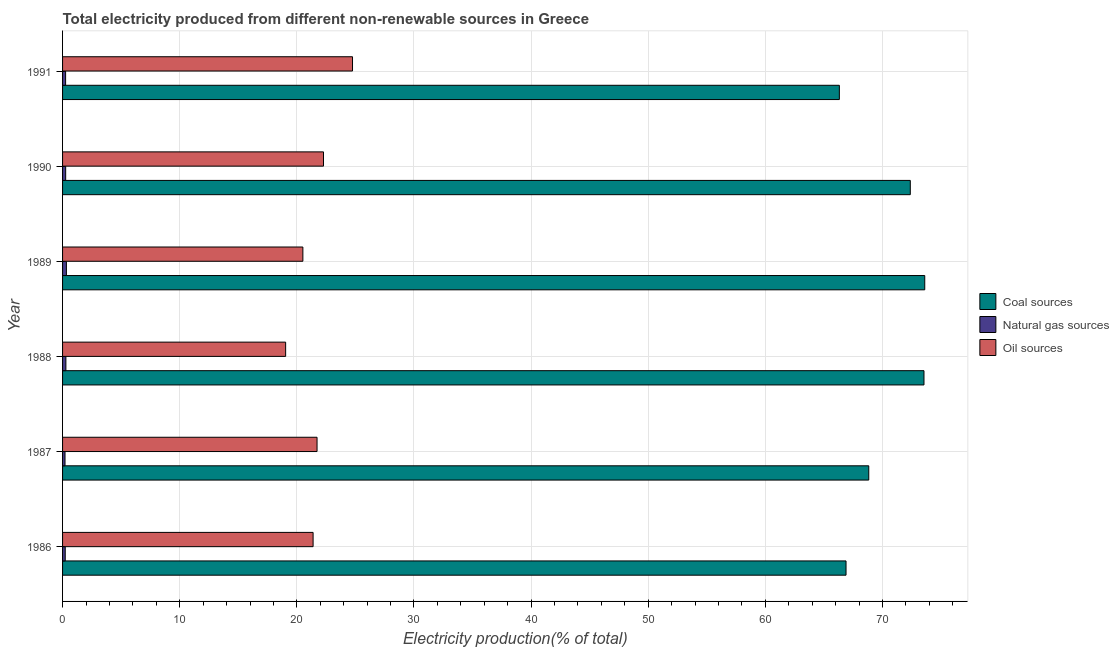How many groups of bars are there?
Your answer should be very brief. 6. Are the number of bars per tick equal to the number of legend labels?
Ensure brevity in your answer.  Yes. Are the number of bars on each tick of the Y-axis equal?
Your answer should be compact. Yes. How many bars are there on the 2nd tick from the bottom?
Offer a terse response. 3. In how many cases, is the number of bars for a given year not equal to the number of legend labels?
Provide a short and direct response. 0. What is the percentage of electricity produced by oil sources in 1991?
Offer a very short reply. 24.75. Across all years, what is the maximum percentage of electricity produced by natural gas?
Provide a short and direct response. 0.33. Across all years, what is the minimum percentage of electricity produced by coal?
Make the answer very short. 66.31. In which year was the percentage of electricity produced by coal maximum?
Your answer should be compact. 1989. What is the total percentage of electricity produced by coal in the graph?
Your response must be concise. 421.52. What is the difference between the percentage of electricity produced by oil sources in 1989 and that in 1990?
Make the answer very short. -1.76. What is the difference between the percentage of electricity produced by oil sources in 1988 and the percentage of electricity produced by natural gas in 1989?
Provide a succinct answer. 18.72. What is the average percentage of electricity produced by natural gas per year?
Give a very brief answer. 0.26. In the year 1989, what is the difference between the percentage of electricity produced by oil sources and percentage of electricity produced by natural gas?
Offer a terse response. 20.19. What is the ratio of the percentage of electricity produced by coal in 1989 to that in 1991?
Offer a very short reply. 1.11. What is the difference between the highest and the second highest percentage of electricity produced by natural gas?
Ensure brevity in your answer.  0.04. What is the difference between the highest and the lowest percentage of electricity produced by natural gas?
Keep it short and to the point. 0.12. What does the 3rd bar from the top in 1987 represents?
Offer a terse response. Coal sources. What does the 2nd bar from the bottom in 1986 represents?
Your response must be concise. Natural gas sources. Is it the case that in every year, the sum of the percentage of electricity produced by coal and percentage of electricity produced by natural gas is greater than the percentage of electricity produced by oil sources?
Offer a very short reply. Yes. How many bars are there?
Keep it short and to the point. 18. Are all the bars in the graph horizontal?
Provide a succinct answer. Yes. How many years are there in the graph?
Provide a short and direct response. 6. What is the difference between two consecutive major ticks on the X-axis?
Ensure brevity in your answer.  10. Are the values on the major ticks of X-axis written in scientific E-notation?
Keep it short and to the point. No. Does the graph contain any zero values?
Provide a succinct answer. No. Does the graph contain grids?
Offer a terse response. Yes. Where does the legend appear in the graph?
Keep it short and to the point. Center right. How many legend labels are there?
Keep it short and to the point. 3. What is the title of the graph?
Your answer should be compact. Total electricity produced from different non-renewable sources in Greece. Does "Social Insurance" appear as one of the legend labels in the graph?
Provide a succinct answer. No. What is the label or title of the Y-axis?
Make the answer very short. Year. What is the Electricity production(% of total) in Coal sources in 1986?
Ensure brevity in your answer.  66.88. What is the Electricity production(% of total) of Natural gas sources in 1986?
Give a very brief answer. 0.23. What is the Electricity production(% of total) of Oil sources in 1986?
Your answer should be compact. 21.39. What is the Electricity production(% of total) of Coal sources in 1987?
Your response must be concise. 68.82. What is the Electricity production(% of total) of Natural gas sources in 1987?
Ensure brevity in your answer.  0.21. What is the Electricity production(% of total) of Oil sources in 1987?
Your response must be concise. 21.72. What is the Electricity production(% of total) in Coal sources in 1988?
Offer a terse response. 73.54. What is the Electricity production(% of total) in Natural gas sources in 1988?
Your response must be concise. 0.28. What is the Electricity production(% of total) of Oil sources in 1988?
Provide a succinct answer. 19.04. What is the Electricity production(% of total) in Coal sources in 1989?
Provide a short and direct response. 73.6. What is the Electricity production(% of total) of Natural gas sources in 1989?
Offer a terse response. 0.33. What is the Electricity production(% of total) of Oil sources in 1989?
Keep it short and to the point. 20.51. What is the Electricity production(% of total) of Coal sources in 1990?
Make the answer very short. 72.37. What is the Electricity production(% of total) in Natural gas sources in 1990?
Provide a succinct answer. 0.26. What is the Electricity production(% of total) of Oil sources in 1990?
Offer a very short reply. 22.27. What is the Electricity production(% of total) in Coal sources in 1991?
Ensure brevity in your answer.  66.31. What is the Electricity production(% of total) of Natural gas sources in 1991?
Provide a succinct answer. 0.26. What is the Electricity production(% of total) of Oil sources in 1991?
Offer a very short reply. 24.75. Across all years, what is the maximum Electricity production(% of total) of Coal sources?
Your response must be concise. 73.6. Across all years, what is the maximum Electricity production(% of total) in Natural gas sources?
Your answer should be very brief. 0.33. Across all years, what is the maximum Electricity production(% of total) of Oil sources?
Ensure brevity in your answer.  24.75. Across all years, what is the minimum Electricity production(% of total) in Coal sources?
Your answer should be very brief. 66.31. Across all years, what is the minimum Electricity production(% of total) in Natural gas sources?
Your response must be concise. 0.21. Across all years, what is the minimum Electricity production(% of total) in Oil sources?
Ensure brevity in your answer.  19.04. What is the total Electricity production(% of total) of Coal sources in the graph?
Ensure brevity in your answer.  421.52. What is the total Electricity production(% of total) in Natural gas sources in the graph?
Ensure brevity in your answer.  1.57. What is the total Electricity production(% of total) in Oil sources in the graph?
Make the answer very short. 129.7. What is the difference between the Electricity production(% of total) in Coal sources in 1986 and that in 1987?
Your response must be concise. -1.94. What is the difference between the Electricity production(% of total) of Natural gas sources in 1986 and that in 1987?
Make the answer very short. 0.02. What is the difference between the Electricity production(% of total) in Oil sources in 1986 and that in 1987?
Your response must be concise. -0.34. What is the difference between the Electricity production(% of total) in Coal sources in 1986 and that in 1988?
Keep it short and to the point. -6.65. What is the difference between the Electricity production(% of total) in Natural gas sources in 1986 and that in 1988?
Ensure brevity in your answer.  -0.06. What is the difference between the Electricity production(% of total) in Oil sources in 1986 and that in 1988?
Give a very brief answer. 2.34. What is the difference between the Electricity production(% of total) of Coal sources in 1986 and that in 1989?
Make the answer very short. -6.72. What is the difference between the Electricity production(% of total) of Natural gas sources in 1986 and that in 1989?
Your answer should be compact. -0.1. What is the difference between the Electricity production(% of total) of Oil sources in 1986 and that in 1989?
Provide a short and direct response. 0.87. What is the difference between the Electricity production(% of total) in Coal sources in 1986 and that in 1990?
Ensure brevity in your answer.  -5.49. What is the difference between the Electricity production(% of total) of Natural gas sources in 1986 and that in 1990?
Your answer should be very brief. -0.04. What is the difference between the Electricity production(% of total) in Oil sources in 1986 and that in 1990?
Make the answer very short. -0.89. What is the difference between the Electricity production(% of total) in Coal sources in 1986 and that in 1991?
Offer a very short reply. 0.57. What is the difference between the Electricity production(% of total) in Natural gas sources in 1986 and that in 1991?
Offer a very short reply. -0.03. What is the difference between the Electricity production(% of total) in Oil sources in 1986 and that in 1991?
Your response must be concise. -3.36. What is the difference between the Electricity production(% of total) in Coal sources in 1987 and that in 1988?
Your response must be concise. -4.71. What is the difference between the Electricity production(% of total) in Natural gas sources in 1987 and that in 1988?
Your answer should be compact. -0.07. What is the difference between the Electricity production(% of total) of Oil sources in 1987 and that in 1988?
Your response must be concise. 2.68. What is the difference between the Electricity production(% of total) of Coal sources in 1987 and that in 1989?
Keep it short and to the point. -4.78. What is the difference between the Electricity production(% of total) in Natural gas sources in 1987 and that in 1989?
Make the answer very short. -0.12. What is the difference between the Electricity production(% of total) of Oil sources in 1987 and that in 1989?
Offer a very short reply. 1.21. What is the difference between the Electricity production(% of total) of Coal sources in 1987 and that in 1990?
Offer a terse response. -3.55. What is the difference between the Electricity production(% of total) of Natural gas sources in 1987 and that in 1990?
Your response must be concise. -0.06. What is the difference between the Electricity production(% of total) in Oil sources in 1987 and that in 1990?
Provide a succinct answer. -0.55. What is the difference between the Electricity production(% of total) in Coal sources in 1987 and that in 1991?
Your response must be concise. 2.51. What is the difference between the Electricity production(% of total) of Natural gas sources in 1987 and that in 1991?
Your response must be concise. -0.05. What is the difference between the Electricity production(% of total) in Oil sources in 1987 and that in 1991?
Your answer should be compact. -3.03. What is the difference between the Electricity production(% of total) of Coal sources in 1988 and that in 1989?
Provide a short and direct response. -0.07. What is the difference between the Electricity production(% of total) of Natural gas sources in 1988 and that in 1989?
Offer a very short reply. -0.04. What is the difference between the Electricity production(% of total) in Oil sources in 1988 and that in 1989?
Keep it short and to the point. -1.47. What is the difference between the Electricity production(% of total) of Coal sources in 1988 and that in 1990?
Keep it short and to the point. 1.17. What is the difference between the Electricity production(% of total) of Natural gas sources in 1988 and that in 1990?
Give a very brief answer. 0.02. What is the difference between the Electricity production(% of total) in Oil sources in 1988 and that in 1990?
Keep it short and to the point. -3.23. What is the difference between the Electricity production(% of total) of Coal sources in 1988 and that in 1991?
Keep it short and to the point. 7.22. What is the difference between the Electricity production(% of total) in Natural gas sources in 1988 and that in 1991?
Keep it short and to the point. 0.02. What is the difference between the Electricity production(% of total) of Oil sources in 1988 and that in 1991?
Your answer should be compact. -5.71. What is the difference between the Electricity production(% of total) in Coal sources in 1989 and that in 1990?
Ensure brevity in your answer.  1.23. What is the difference between the Electricity production(% of total) in Natural gas sources in 1989 and that in 1990?
Provide a succinct answer. 0.06. What is the difference between the Electricity production(% of total) of Oil sources in 1989 and that in 1990?
Your answer should be very brief. -1.76. What is the difference between the Electricity production(% of total) of Coal sources in 1989 and that in 1991?
Your response must be concise. 7.29. What is the difference between the Electricity production(% of total) of Natural gas sources in 1989 and that in 1991?
Keep it short and to the point. 0.07. What is the difference between the Electricity production(% of total) of Oil sources in 1989 and that in 1991?
Your answer should be very brief. -4.24. What is the difference between the Electricity production(% of total) of Coal sources in 1990 and that in 1991?
Ensure brevity in your answer.  6.06. What is the difference between the Electricity production(% of total) of Natural gas sources in 1990 and that in 1991?
Your answer should be very brief. 0. What is the difference between the Electricity production(% of total) in Oil sources in 1990 and that in 1991?
Offer a very short reply. -2.48. What is the difference between the Electricity production(% of total) of Coal sources in 1986 and the Electricity production(% of total) of Natural gas sources in 1987?
Offer a very short reply. 66.67. What is the difference between the Electricity production(% of total) in Coal sources in 1986 and the Electricity production(% of total) in Oil sources in 1987?
Provide a succinct answer. 45.16. What is the difference between the Electricity production(% of total) in Natural gas sources in 1986 and the Electricity production(% of total) in Oil sources in 1987?
Offer a terse response. -21.5. What is the difference between the Electricity production(% of total) in Coal sources in 1986 and the Electricity production(% of total) in Natural gas sources in 1988?
Your answer should be compact. 66.6. What is the difference between the Electricity production(% of total) in Coal sources in 1986 and the Electricity production(% of total) in Oil sources in 1988?
Make the answer very short. 47.84. What is the difference between the Electricity production(% of total) of Natural gas sources in 1986 and the Electricity production(% of total) of Oil sources in 1988?
Give a very brief answer. -18.82. What is the difference between the Electricity production(% of total) in Coal sources in 1986 and the Electricity production(% of total) in Natural gas sources in 1989?
Provide a succinct answer. 66.56. What is the difference between the Electricity production(% of total) of Coal sources in 1986 and the Electricity production(% of total) of Oil sources in 1989?
Give a very brief answer. 46.37. What is the difference between the Electricity production(% of total) in Natural gas sources in 1986 and the Electricity production(% of total) in Oil sources in 1989?
Make the answer very short. -20.29. What is the difference between the Electricity production(% of total) of Coal sources in 1986 and the Electricity production(% of total) of Natural gas sources in 1990?
Your answer should be compact. 66.62. What is the difference between the Electricity production(% of total) of Coal sources in 1986 and the Electricity production(% of total) of Oil sources in 1990?
Offer a terse response. 44.61. What is the difference between the Electricity production(% of total) of Natural gas sources in 1986 and the Electricity production(% of total) of Oil sources in 1990?
Keep it short and to the point. -22.05. What is the difference between the Electricity production(% of total) of Coal sources in 1986 and the Electricity production(% of total) of Natural gas sources in 1991?
Provide a succinct answer. 66.62. What is the difference between the Electricity production(% of total) of Coal sources in 1986 and the Electricity production(% of total) of Oil sources in 1991?
Make the answer very short. 42.13. What is the difference between the Electricity production(% of total) in Natural gas sources in 1986 and the Electricity production(% of total) in Oil sources in 1991?
Offer a very short reply. -24.52. What is the difference between the Electricity production(% of total) of Coal sources in 1987 and the Electricity production(% of total) of Natural gas sources in 1988?
Your answer should be very brief. 68.54. What is the difference between the Electricity production(% of total) in Coal sources in 1987 and the Electricity production(% of total) in Oil sources in 1988?
Give a very brief answer. 49.78. What is the difference between the Electricity production(% of total) in Natural gas sources in 1987 and the Electricity production(% of total) in Oil sources in 1988?
Offer a terse response. -18.83. What is the difference between the Electricity production(% of total) in Coal sources in 1987 and the Electricity production(% of total) in Natural gas sources in 1989?
Keep it short and to the point. 68.5. What is the difference between the Electricity production(% of total) in Coal sources in 1987 and the Electricity production(% of total) in Oil sources in 1989?
Your response must be concise. 48.31. What is the difference between the Electricity production(% of total) in Natural gas sources in 1987 and the Electricity production(% of total) in Oil sources in 1989?
Ensure brevity in your answer.  -20.31. What is the difference between the Electricity production(% of total) in Coal sources in 1987 and the Electricity production(% of total) in Natural gas sources in 1990?
Provide a succinct answer. 68.56. What is the difference between the Electricity production(% of total) of Coal sources in 1987 and the Electricity production(% of total) of Oil sources in 1990?
Provide a short and direct response. 46.55. What is the difference between the Electricity production(% of total) in Natural gas sources in 1987 and the Electricity production(% of total) in Oil sources in 1990?
Keep it short and to the point. -22.07. What is the difference between the Electricity production(% of total) in Coal sources in 1987 and the Electricity production(% of total) in Natural gas sources in 1991?
Offer a terse response. 68.56. What is the difference between the Electricity production(% of total) in Coal sources in 1987 and the Electricity production(% of total) in Oil sources in 1991?
Ensure brevity in your answer.  44.07. What is the difference between the Electricity production(% of total) of Natural gas sources in 1987 and the Electricity production(% of total) of Oil sources in 1991?
Provide a succinct answer. -24.54. What is the difference between the Electricity production(% of total) in Coal sources in 1988 and the Electricity production(% of total) in Natural gas sources in 1989?
Provide a succinct answer. 73.21. What is the difference between the Electricity production(% of total) of Coal sources in 1988 and the Electricity production(% of total) of Oil sources in 1989?
Offer a very short reply. 53.02. What is the difference between the Electricity production(% of total) of Natural gas sources in 1988 and the Electricity production(% of total) of Oil sources in 1989?
Ensure brevity in your answer.  -20.23. What is the difference between the Electricity production(% of total) of Coal sources in 1988 and the Electricity production(% of total) of Natural gas sources in 1990?
Provide a short and direct response. 73.27. What is the difference between the Electricity production(% of total) of Coal sources in 1988 and the Electricity production(% of total) of Oil sources in 1990?
Provide a succinct answer. 51.26. What is the difference between the Electricity production(% of total) of Natural gas sources in 1988 and the Electricity production(% of total) of Oil sources in 1990?
Provide a succinct answer. -21.99. What is the difference between the Electricity production(% of total) of Coal sources in 1988 and the Electricity production(% of total) of Natural gas sources in 1991?
Your answer should be very brief. 73.28. What is the difference between the Electricity production(% of total) in Coal sources in 1988 and the Electricity production(% of total) in Oil sources in 1991?
Give a very brief answer. 48.78. What is the difference between the Electricity production(% of total) of Natural gas sources in 1988 and the Electricity production(% of total) of Oil sources in 1991?
Ensure brevity in your answer.  -24.47. What is the difference between the Electricity production(% of total) in Coal sources in 1989 and the Electricity production(% of total) in Natural gas sources in 1990?
Your answer should be compact. 73.34. What is the difference between the Electricity production(% of total) of Coal sources in 1989 and the Electricity production(% of total) of Oil sources in 1990?
Your answer should be very brief. 51.33. What is the difference between the Electricity production(% of total) in Natural gas sources in 1989 and the Electricity production(% of total) in Oil sources in 1990?
Give a very brief answer. -21.95. What is the difference between the Electricity production(% of total) of Coal sources in 1989 and the Electricity production(% of total) of Natural gas sources in 1991?
Offer a terse response. 73.34. What is the difference between the Electricity production(% of total) in Coal sources in 1989 and the Electricity production(% of total) in Oil sources in 1991?
Your response must be concise. 48.85. What is the difference between the Electricity production(% of total) in Natural gas sources in 1989 and the Electricity production(% of total) in Oil sources in 1991?
Provide a short and direct response. -24.42. What is the difference between the Electricity production(% of total) in Coal sources in 1990 and the Electricity production(% of total) in Natural gas sources in 1991?
Offer a very short reply. 72.11. What is the difference between the Electricity production(% of total) of Coal sources in 1990 and the Electricity production(% of total) of Oil sources in 1991?
Provide a succinct answer. 47.62. What is the difference between the Electricity production(% of total) in Natural gas sources in 1990 and the Electricity production(% of total) in Oil sources in 1991?
Offer a very short reply. -24.49. What is the average Electricity production(% of total) in Coal sources per year?
Offer a very short reply. 70.25. What is the average Electricity production(% of total) of Natural gas sources per year?
Your response must be concise. 0.26. What is the average Electricity production(% of total) in Oil sources per year?
Offer a terse response. 21.62. In the year 1986, what is the difference between the Electricity production(% of total) of Coal sources and Electricity production(% of total) of Natural gas sources?
Provide a short and direct response. 66.65. In the year 1986, what is the difference between the Electricity production(% of total) of Coal sources and Electricity production(% of total) of Oil sources?
Offer a terse response. 45.49. In the year 1986, what is the difference between the Electricity production(% of total) in Natural gas sources and Electricity production(% of total) in Oil sources?
Your answer should be very brief. -21.16. In the year 1987, what is the difference between the Electricity production(% of total) of Coal sources and Electricity production(% of total) of Natural gas sources?
Your answer should be compact. 68.61. In the year 1987, what is the difference between the Electricity production(% of total) of Coal sources and Electricity production(% of total) of Oil sources?
Your answer should be very brief. 47.1. In the year 1987, what is the difference between the Electricity production(% of total) in Natural gas sources and Electricity production(% of total) in Oil sources?
Provide a short and direct response. -21.52. In the year 1988, what is the difference between the Electricity production(% of total) of Coal sources and Electricity production(% of total) of Natural gas sources?
Provide a short and direct response. 73.25. In the year 1988, what is the difference between the Electricity production(% of total) of Coal sources and Electricity production(% of total) of Oil sources?
Give a very brief answer. 54.49. In the year 1988, what is the difference between the Electricity production(% of total) in Natural gas sources and Electricity production(% of total) in Oil sources?
Give a very brief answer. -18.76. In the year 1989, what is the difference between the Electricity production(% of total) in Coal sources and Electricity production(% of total) in Natural gas sources?
Provide a succinct answer. 73.27. In the year 1989, what is the difference between the Electricity production(% of total) of Coal sources and Electricity production(% of total) of Oil sources?
Make the answer very short. 53.09. In the year 1989, what is the difference between the Electricity production(% of total) in Natural gas sources and Electricity production(% of total) in Oil sources?
Provide a succinct answer. -20.19. In the year 1990, what is the difference between the Electricity production(% of total) in Coal sources and Electricity production(% of total) in Natural gas sources?
Your response must be concise. 72.1. In the year 1990, what is the difference between the Electricity production(% of total) of Coal sources and Electricity production(% of total) of Oil sources?
Your response must be concise. 50.09. In the year 1990, what is the difference between the Electricity production(% of total) in Natural gas sources and Electricity production(% of total) in Oil sources?
Make the answer very short. -22.01. In the year 1991, what is the difference between the Electricity production(% of total) of Coal sources and Electricity production(% of total) of Natural gas sources?
Ensure brevity in your answer.  66.05. In the year 1991, what is the difference between the Electricity production(% of total) of Coal sources and Electricity production(% of total) of Oil sources?
Offer a terse response. 41.56. In the year 1991, what is the difference between the Electricity production(% of total) of Natural gas sources and Electricity production(% of total) of Oil sources?
Keep it short and to the point. -24.49. What is the ratio of the Electricity production(% of total) of Coal sources in 1986 to that in 1987?
Your answer should be very brief. 0.97. What is the ratio of the Electricity production(% of total) of Natural gas sources in 1986 to that in 1987?
Give a very brief answer. 1.09. What is the ratio of the Electricity production(% of total) of Oil sources in 1986 to that in 1987?
Your answer should be very brief. 0.98. What is the ratio of the Electricity production(% of total) of Coal sources in 1986 to that in 1988?
Provide a short and direct response. 0.91. What is the ratio of the Electricity production(% of total) in Natural gas sources in 1986 to that in 1988?
Offer a terse response. 0.8. What is the ratio of the Electricity production(% of total) of Oil sources in 1986 to that in 1988?
Offer a terse response. 1.12. What is the ratio of the Electricity production(% of total) of Coal sources in 1986 to that in 1989?
Your answer should be compact. 0.91. What is the ratio of the Electricity production(% of total) in Natural gas sources in 1986 to that in 1989?
Offer a very short reply. 0.7. What is the ratio of the Electricity production(% of total) in Oil sources in 1986 to that in 1989?
Give a very brief answer. 1.04. What is the ratio of the Electricity production(% of total) in Coal sources in 1986 to that in 1990?
Ensure brevity in your answer.  0.92. What is the ratio of the Electricity production(% of total) in Natural gas sources in 1986 to that in 1990?
Keep it short and to the point. 0.86. What is the ratio of the Electricity production(% of total) of Oil sources in 1986 to that in 1990?
Provide a succinct answer. 0.96. What is the ratio of the Electricity production(% of total) of Coal sources in 1986 to that in 1991?
Keep it short and to the point. 1.01. What is the ratio of the Electricity production(% of total) in Natural gas sources in 1986 to that in 1991?
Your response must be concise. 0.87. What is the ratio of the Electricity production(% of total) in Oil sources in 1986 to that in 1991?
Give a very brief answer. 0.86. What is the ratio of the Electricity production(% of total) of Coal sources in 1987 to that in 1988?
Provide a succinct answer. 0.94. What is the ratio of the Electricity production(% of total) in Natural gas sources in 1987 to that in 1988?
Make the answer very short. 0.74. What is the ratio of the Electricity production(% of total) in Oil sources in 1987 to that in 1988?
Make the answer very short. 1.14. What is the ratio of the Electricity production(% of total) in Coal sources in 1987 to that in 1989?
Offer a terse response. 0.94. What is the ratio of the Electricity production(% of total) in Natural gas sources in 1987 to that in 1989?
Offer a very short reply. 0.64. What is the ratio of the Electricity production(% of total) in Oil sources in 1987 to that in 1989?
Your answer should be very brief. 1.06. What is the ratio of the Electricity production(% of total) in Coal sources in 1987 to that in 1990?
Offer a very short reply. 0.95. What is the ratio of the Electricity production(% of total) of Natural gas sources in 1987 to that in 1990?
Your response must be concise. 0.79. What is the ratio of the Electricity production(% of total) in Oil sources in 1987 to that in 1990?
Offer a terse response. 0.98. What is the ratio of the Electricity production(% of total) of Coal sources in 1987 to that in 1991?
Give a very brief answer. 1.04. What is the ratio of the Electricity production(% of total) in Natural gas sources in 1987 to that in 1991?
Ensure brevity in your answer.  0.8. What is the ratio of the Electricity production(% of total) in Oil sources in 1987 to that in 1991?
Provide a short and direct response. 0.88. What is the ratio of the Electricity production(% of total) of Coal sources in 1988 to that in 1989?
Keep it short and to the point. 1. What is the ratio of the Electricity production(% of total) of Natural gas sources in 1988 to that in 1989?
Give a very brief answer. 0.87. What is the ratio of the Electricity production(% of total) in Oil sources in 1988 to that in 1989?
Ensure brevity in your answer.  0.93. What is the ratio of the Electricity production(% of total) of Coal sources in 1988 to that in 1990?
Give a very brief answer. 1.02. What is the ratio of the Electricity production(% of total) of Natural gas sources in 1988 to that in 1990?
Offer a terse response. 1.07. What is the ratio of the Electricity production(% of total) of Oil sources in 1988 to that in 1990?
Keep it short and to the point. 0.85. What is the ratio of the Electricity production(% of total) of Coal sources in 1988 to that in 1991?
Your answer should be very brief. 1.11. What is the ratio of the Electricity production(% of total) in Natural gas sources in 1988 to that in 1991?
Your response must be concise. 1.09. What is the ratio of the Electricity production(% of total) of Oil sources in 1988 to that in 1991?
Provide a succinct answer. 0.77. What is the ratio of the Electricity production(% of total) in Natural gas sources in 1989 to that in 1990?
Your answer should be compact. 1.24. What is the ratio of the Electricity production(% of total) in Oil sources in 1989 to that in 1990?
Keep it short and to the point. 0.92. What is the ratio of the Electricity production(% of total) in Coal sources in 1989 to that in 1991?
Your answer should be compact. 1.11. What is the ratio of the Electricity production(% of total) of Natural gas sources in 1989 to that in 1991?
Keep it short and to the point. 1.26. What is the ratio of the Electricity production(% of total) in Oil sources in 1989 to that in 1991?
Your answer should be compact. 0.83. What is the ratio of the Electricity production(% of total) in Coal sources in 1990 to that in 1991?
Your response must be concise. 1.09. What is the ratio of the Electricity production(% of total) of Natural gas sources in 1990 to that in 1991?
Keep it short and to the point. 1.02. What is the ratio of the Electricity production(% of total) in Oil sources in 1990 to that in 1991?
Ensure brevity in your answer.  0.9. What is the difference between the highest and the second highest Electricity production(% of total) of Coal sources?
Ensure brevity in your answer.  0.07. What is the difference between the highest and the second highest Electricity production(% of total) of Natural gas sources?
Give a very brief answer. 0.04. What is the difference between the highest and the second highest Electricity production(% of total) of Oil sources?
Your response must be concise. 2.48. What is the difference between the highest and the lowest Electricity production(% of total) of Coal sources?
Make the answer very short. 7.29. What is the difference between the highest and the lowest Electricity production(% of total) in Natural gas sources?
Ensure brevity in your answer.  0.12. What is the difference between the highest and the lowest Electricity production(% of total) of Oil sources?
Offer a terse response. 5.71. 